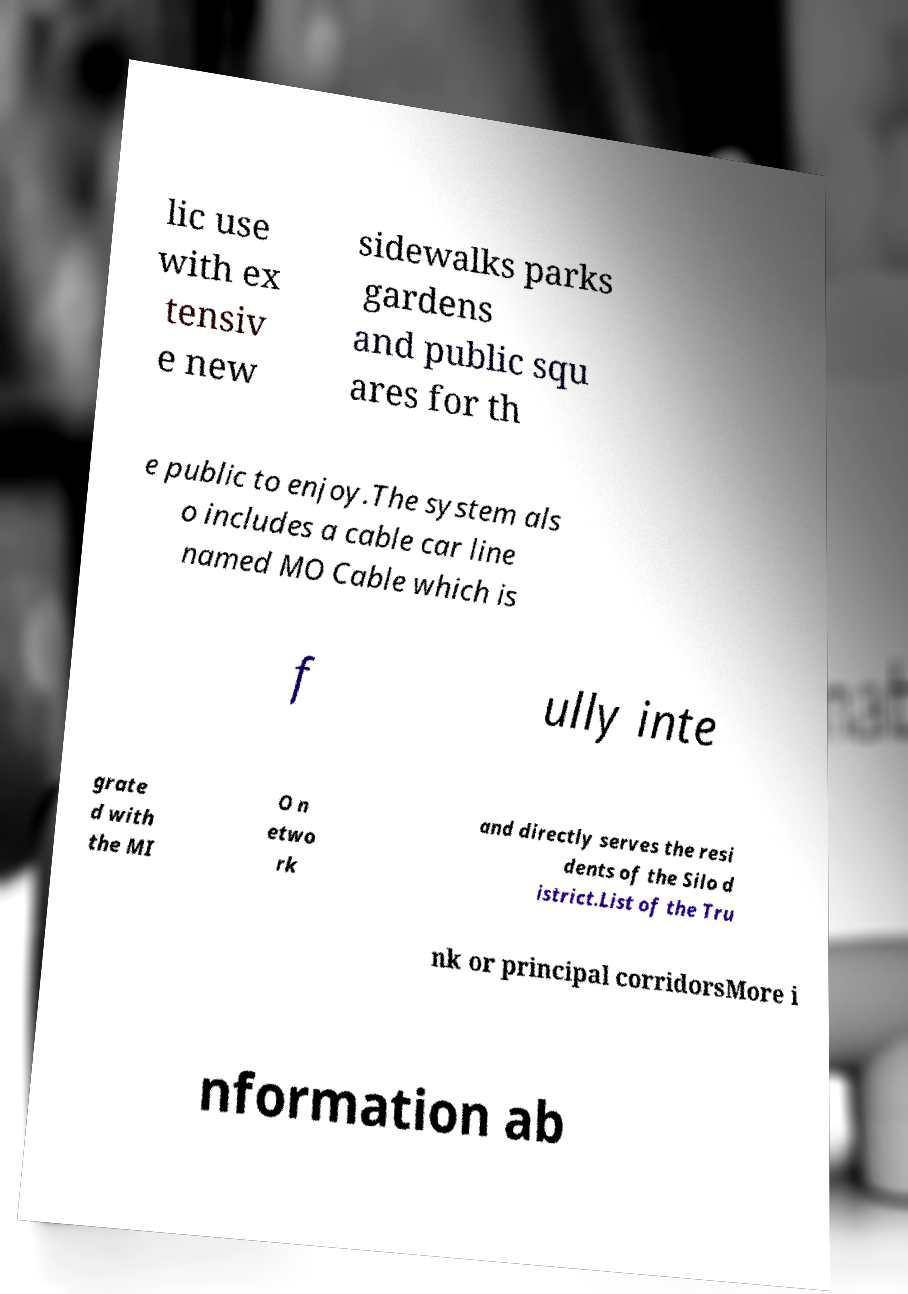For documentation purposes, I need the text within this image transcribed. Could you provide that? lic use with ex tensiv e new sidewalks parks gardens and public squ ares for th e public to enjoy.The system als o includes a cable car line named MO Cable which is f ully inte grate d with the MI O n etwo rk and directly serves the resi dents of the Silo d istrict.List of the Tru nk or principal corridorsMore i nformation ab 